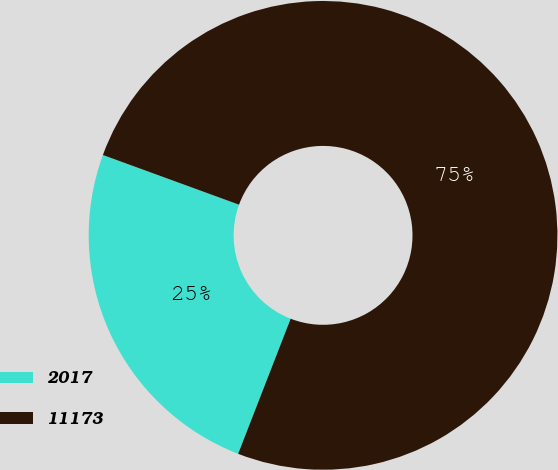Convert chart to OTSL. <chart><loc_0><loc_0><loc_500><loc_500><pie_chart><fcel>2017<fcel>11173<nl><fcel>24.67%<fcel>75.33%<nl></chart> 